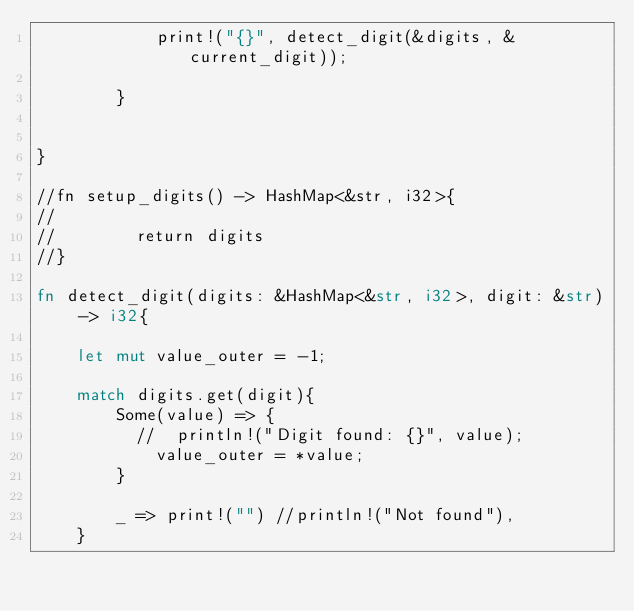Convert code to text. <code><loc_0><loc_0><loc_500><loc_500><_Rust_>            print!("{}", detect_digit(&digits, &current_digit));

        }


}

//fn setup_digits() -> HashMap<&str, i32>{
//   
//        return digits
//}

fn detect_digit(digits: &HashMap<&str, i32>, digit: &str) -> i32{
    
    let mut value_outer = -1;
 
    match digits.get(digit){
        Some(value) => {
          //  println!("Digit found: {}", value);
            value_outer = *value;
        }
        
        _ => print!("") //println!("Not found"),
    }

</code> 